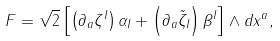<formula> <loc_0><loc_0><loc_500><loc_500>F = \sqrt { 2 } \left [ { \left ( { \partial _ { a } \zeta ^ { I } } \right ) \alpha _ { I } + \left ( { \partial _ { a } \tilde { \zeta } _ { I } } \right ) \beta ^ { I } } \right ] \wedge d x ^ { a } ,</formula> 